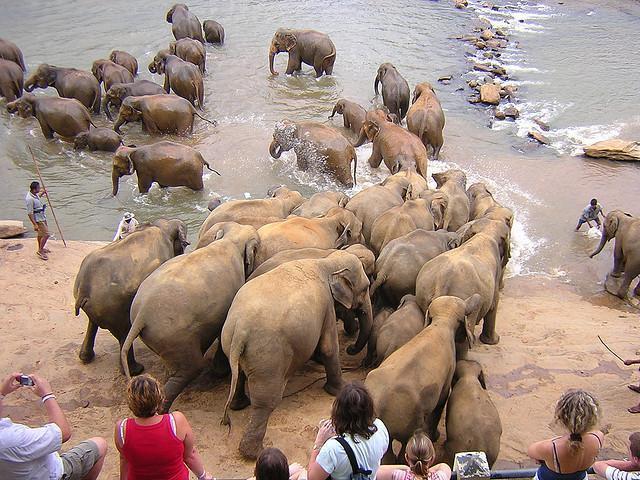Why is the man holding a camera?
Choose the right answer from the provided options to respond to the question.
Options: Buying it, selling it, taking pictures, weighing it. Taking pictures. 